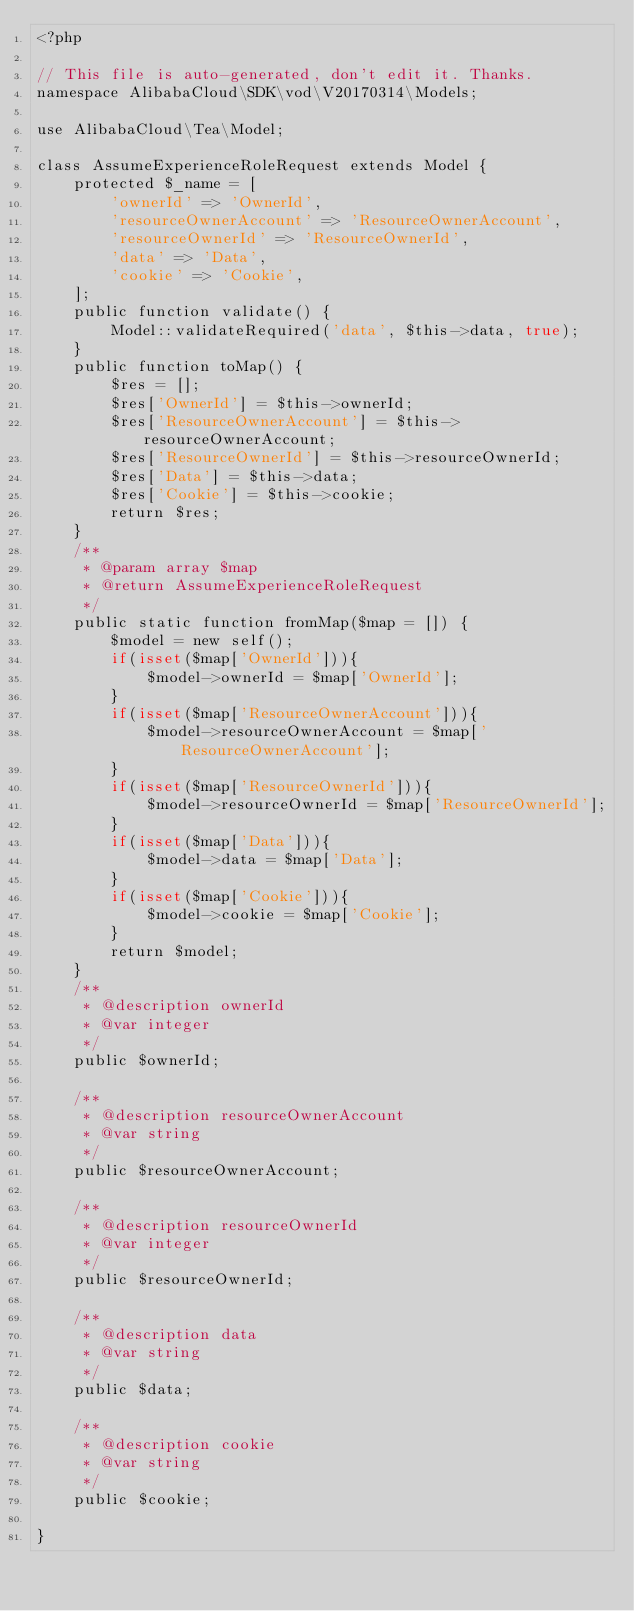<code> <loc_0><loc_0><loc_500><loc_500><_PHP_><?php

// This file is auto-generated, don't edit it. Thanks.
namespace AlibabaCloud\SDK\vod\V20170314\Models;

use AlibabaCloud\Tea\Model;

class AssumeExperienceRoleRequest extends Model {
    protected $_name = [
        'ownerId' => 'OwnerId',
        'resourceOwnerAccount' => 'ResourceOwnerAccount',
        'resourceOwnerId' => 'ResourceOwnerId',
        'data' => 'Data',
        'cookie' => 'Cookie',
    ];
    public function validate() {
        Model::validateRequired('data', $this->data, true);
    }
    public function toMap() {
        $res = [];
        $res['OwnerId'] = $this->ownerId;
        $res['ResourceOwnerAccount'] = $this->resourceOwnerAccount;
        $res['ResourceOwnerId'] = $this->resourceOwnerId;
        $res['Data'] = $this->data;
        $res['Cookie'] = $this->cookie;
        return $res;
    }
    /**
     * @param array $map
     * @return AssumeExperienceRoleRequest
     */
    public static function fromMap($map = []) {
        $model = new self();
        if(isset($map['OwnerId'])){
            $model->ownerId = $map['OwnerId'];
        }
        if(isset($map['ResourceOwnerAccount'])){
            $model->resourceOwnerAccount = $map['ResourceOwnerAccount'];
        }
        if(isset($map['ResourceOwnerId'])){
            $model->resourceOwnerId = $map['ResourceOwnerId'];
        }
        if(isset($map['Data'])){
            $model->data = $map['Data'];
        }
        if(isset($map['Cookie'])){
            $model->cookie = $map['Cookie'];
        }
        return $model;
    }
    /**
     * @description ownerId
     * @var integer
     */
    public $ownerId;

    /**
     * @description resourceOwnerAccount
     * @var string
     */
    public $resourceOwnerAccount;

    /**
     * @description resourceOwnerId
     * @var integer
     */
    public $resourceOwnerId;

    /**
     * @description data
     * @var string
     */
    public $data;

    /**
     * @description cookie
     * @var string
     */
    public $cookie;

}
</code> 